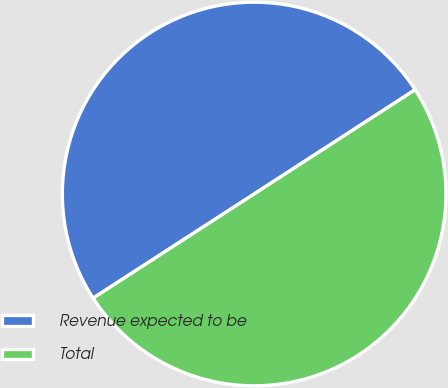<chart> <loc_0><loc_0><loc_500><loc_500><pie_chart><fcel>Revenue expected to be<fcel>Total<nl><fcel>49.99%<fcel>50.01%<nl></chart> 